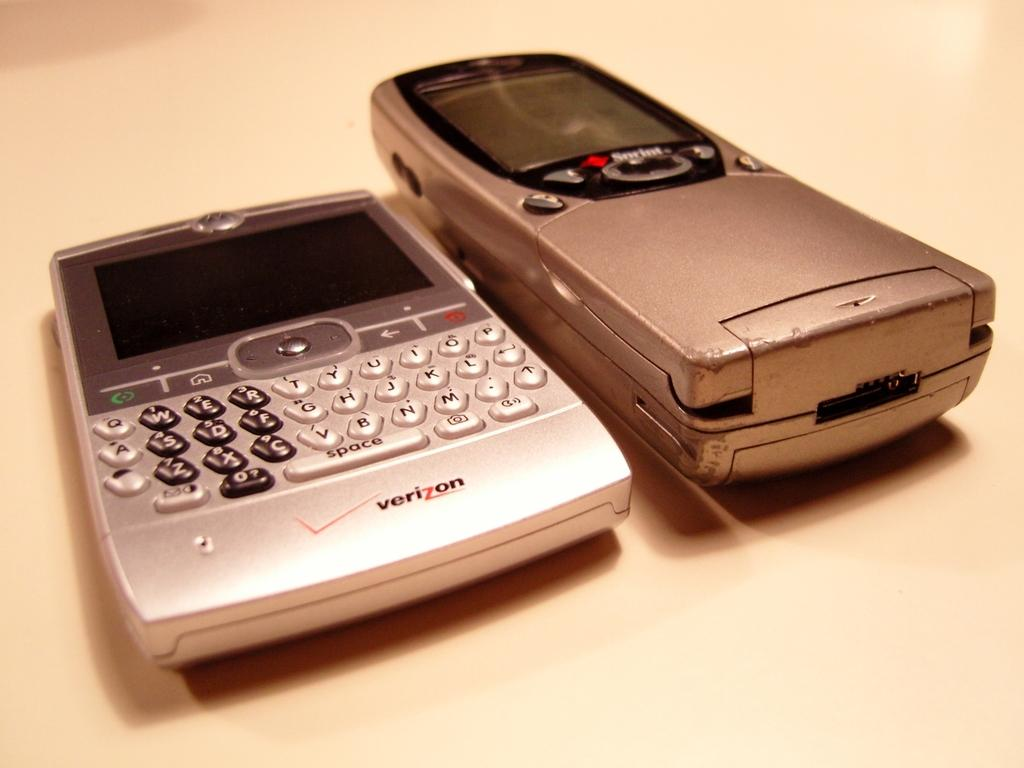<image>
Summarize the visual content of the image. A Sprint phone and a Verizon device sit side by side. 